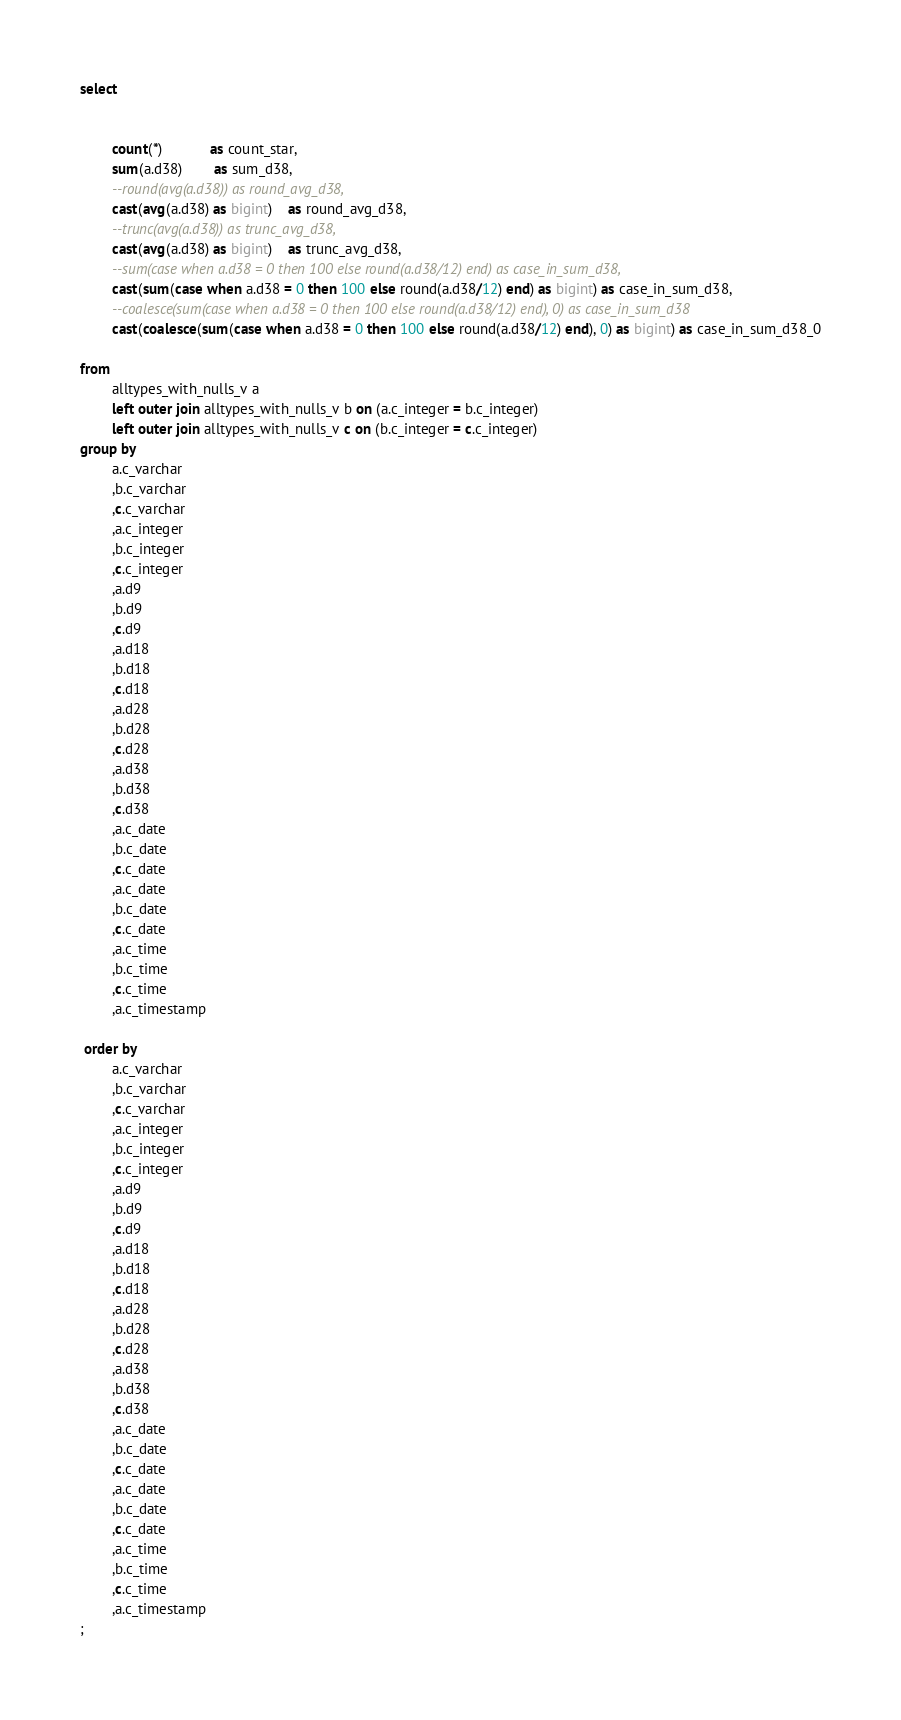Convert code to text. <code><loc_0><loc_0><loc_500><loc_500><_SQL_>select

				
		count(*)			as count_star,
 		sum(a.d38)		as sum_d38,
 		--round(avg(a.d38))	as round_avg_d38,
 		cast(avg(a.d38) as bigint)	as round_avg_d38,
 		--trunc(avg(a.d38))	as trunc_avg_d38,
 		cast(avg(a.d38) as bigint)	as trunc_avg_d38,
 		--sum(case when a.d38 = 0 then 100 else round(a.d38/12) end) as case_in_sum_d38,
 		cast(sum(case when a.d38 = 0 then 100 else round(a.d38/12) end) as bigint) as case_in_sum_d38,
 		--coalesce(sum(case when a.d38 = 0 then 100 else round(a.d38/12) end), 0) as case_in_sum_d38
 		cast(coalesce(sum(case when a.d38 = 0 then 100 else round(a.d38/12) end), 0) as bigint) as case_in_sum_d38_0
 
from
 		alltypes_with_nulls_v a
		left outer join alltypes_with_nulls_v b on (a.c_integer = b.c_integer)
		left outer join alltypes_with_nulls_v c on (b.c_integer = c.c_integer)
group by
  		a.c_varchar
 		,b.c_varchar
 		,c.c_varchar
 		,a.c_integer
 		,b.c_integer
 		,c.c_integer
 		,a.d9
 		,b.d9
 		,c.d9
 		,a.d18
 		,b.d18
 		,c.d18
 		,a.d28
 		,b.d28
 		,c.d28
 		,a.d38
 		,b.d38
 		,c.d38
 		,a.c_date
 		,b.c_date
 		,c.c_date
 		,a.c_date
 		,b.c_date
 		,c.c_date
 		,a.c_time
 		,b.c_time
 		,c.c_time
 		,a.c_timestamp

 order by
  		a.c_varchar
 		,b.c_varchar
 		,c.c_varchar
 		,a.c_integer
 		,b.c_integer
 		,c.c_integer
 		,a.d9
 		,b.d9
 		,c.d9
 		,a.d18
 		,b.d18
 		,c.d18
 		,a.d28
 		,b.d28
 		,c.d28
 		,a.d38
 		,b.d38
 		,c.d38
 		,a.c_date
 		,b.c_date
 		,c.c_date
 		,a.c_date
 		,b.c_date
 		,c.c_date
 		,a.c_time
 		,b.c_time
 		,c.c_time
 		,a.c_timestamp
;
</code> 